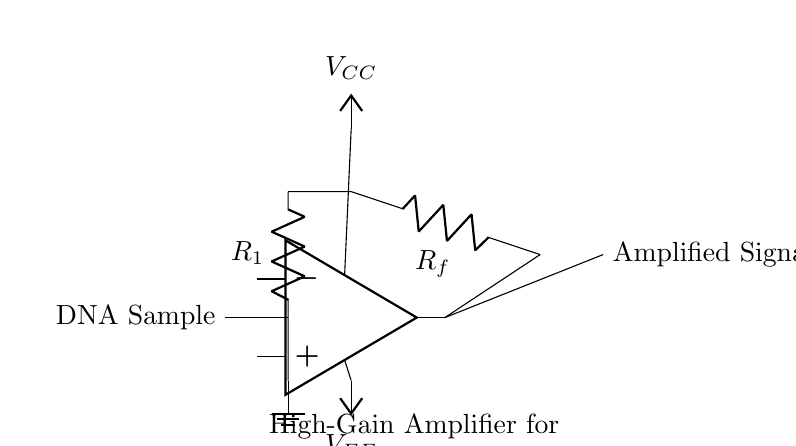What is the purpose of R1 in the circuit? R1 is a resistor that serves to limit the current flowing from the DNA sample into the operational amplifier, safeguarding it from excessive input currents.
Answer: Current limiting What type of circuit is represented here? This is a high-gain amplifier circuit, specifically designed to amplify weak signals, such as those from DNA samples, for improved detection during electrophoresis.
Answer: High-gain amplifier What component is used to amplify the signal? The operational amplifier marked in the diagram is the component specifically designed to amplify the input signal taken from the DNA sample.
Answer: Operational amplifier What are the values for voltage supply VCC and VEE? The diagram does not specify numerical values for VCC and VEE; typically, VCC is positive and VEE is negative, providing the necessary power for amplification.
Answer: Not specified How does the feedback resistor Rf affect gain? The feedback resistor Rf creates a feedback loop that stabilizes the amplifier and sets the gain of the amplifier, which is determined by the ratio of Rf to R1.
Answer: Gain adjustment What is the output of the amplifier? The output of the amplifier is labeled as "Amplified Signal" in the circuit diagram, indicating that it provides a stronger version of the input signal for further processing.
Answer: Amplified Signal 